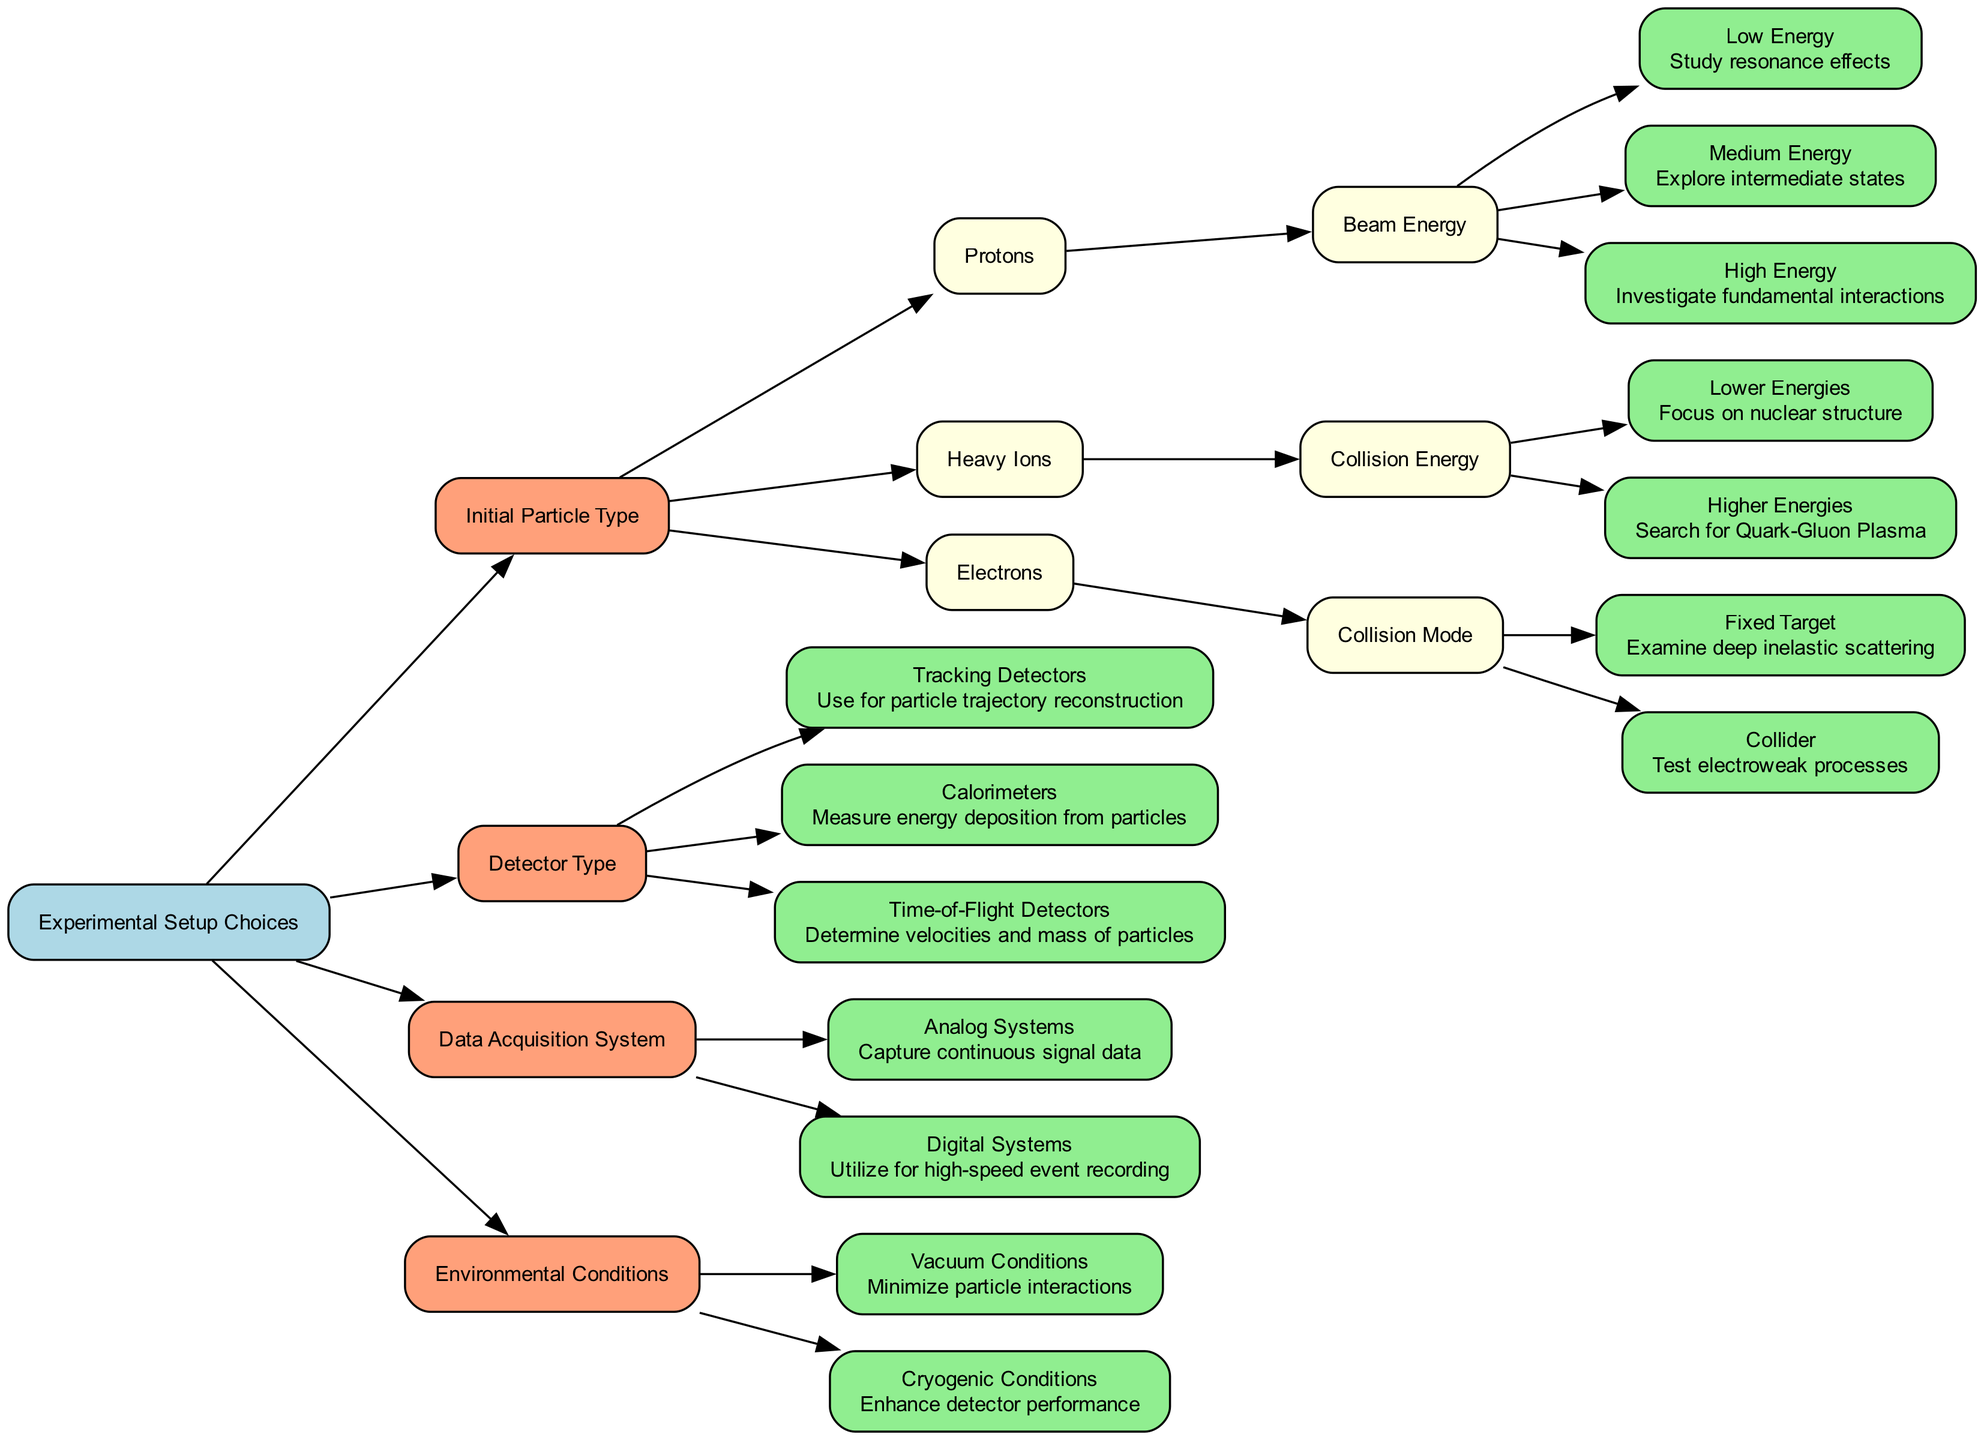What is the initial particle type associated with high energy in the decision tree? The decision tree shows that the high energy option is related to protons, specifically under the "Initial Particle Type" category.
Answer: Protons How many follow-up options are there for the "Initial Particle Type"? There are three initial particle types: Protons, Heavy Ions, and Electrons. Each type has its own follow-up options. Thus, there are a total of three follow-up paths.
Answer: Three What is the purpose of using tracking detectors according to the diagram? The diagram specifies that tracking detectors are used for particle trajectory reconstruction, which is explicitly mentioned in the node for "Tracking Detectors".
Answer: Particle trajectory reconstruction Which collision mode is available for electrons? Based on the decision tree, the available collision modes for electrons are "Fixed Target" and "Collider". The question points out the options provided specifically for electrons.
Answer: Fixed Target or Collider If one wants to study resonance effects, which beam energy should they choose? The diagram indicates that studying resonance effects is associated with the "Low Energy" option under the "Beam Energy" follow-up for protons.
Answer: Low Energy What effect do vacuum conditions have in the experimental setup? According to the diagram, vacuum conditions are selected to minimize particle interactions, which is noted in the "Environmental Conditions" section.
Answer: Minimize particle interactions How many types of detector types are listed in the diagram? The diagram lists three types of detectors: Tracking Detectors, Calorimeters, and Time-of-Flight Detectors, which are explicitly stated under the "Detector Type" category.
Answer: Three What system should be used for high-speed event recording? The diagram specifies that digital systems are utilized for high-speed event recording, which is clearly indicated in the "Data Acquisition System" section.
Answer: Digital Systems For heavy ions at higher energies, what is the research focus? The diagram shows that when using heavy ions at higher energies, the focus of research is to search for Quark-Gluon Plasma, indicated under the "Higher Energies" option.
Answer: Search for Quark-Gluon Plasma 